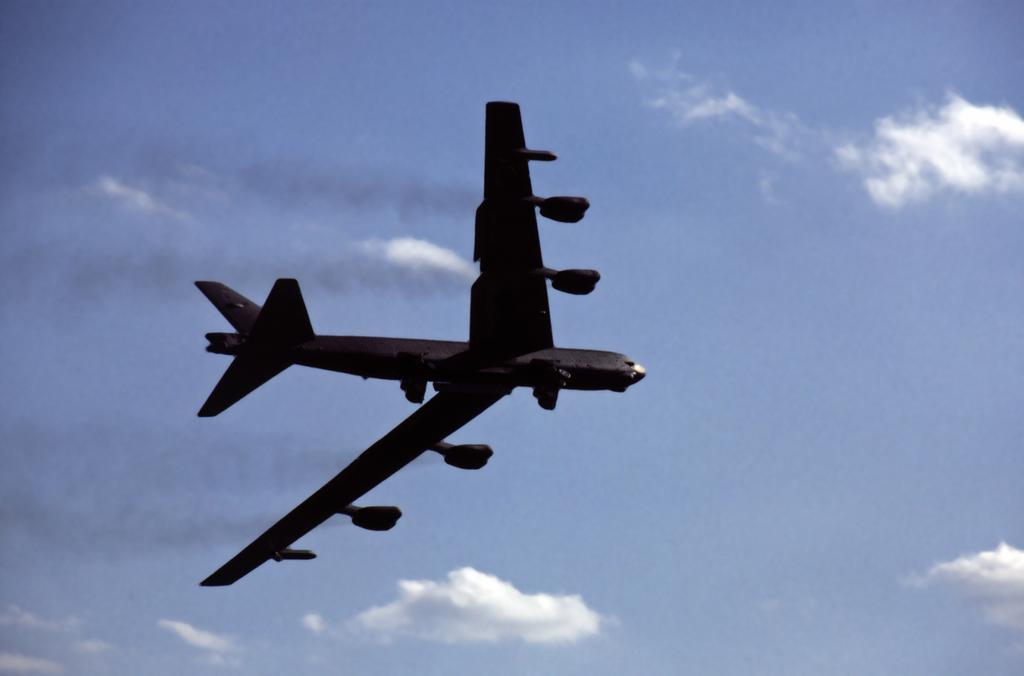What is the main subject of the image? The main subject of the image is an aeroplane. What is the aeroplane doing in the image? The aeroplane is flying in the sky. What else can be seen in the sky in the image? There are clouds visible in the sky. How many arms can be seen on the aeroplane in the image? Aeroplanes do not have arms; they have wings. What type of lift is being used by the chickens in the image? There are no chickens present in the image. 